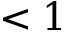Convert formula to latex. <formula><loc_0><loc_0><loc_500><loc_500>< 1</formula> 